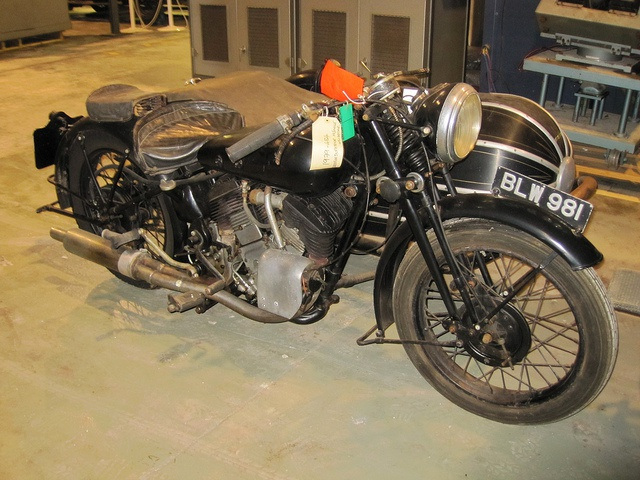Describe the objects in this image and their specific colors. I can see a motorcycle in maroon, black, gray, and tan tones in this image. 